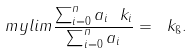<formula> <loc_0><loc_0><loc_500><loc_500>\ m y l i m \frac { \sum _ { i = 0 } ^ { n } a _ { i } \ k _ { i } } { \sum _ { i = 0 } ^ { n } a _ { i } } = \ k _ { \i } .</formula> 